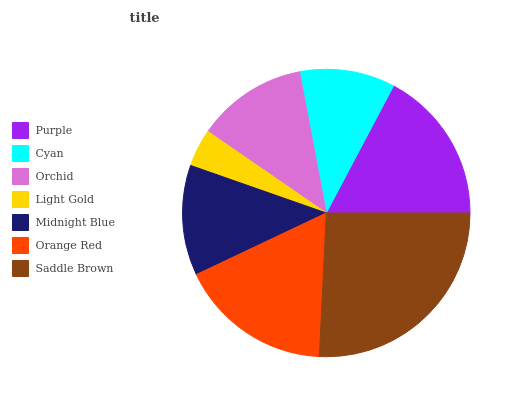Is Light Gold the minimum?
Answer yes or no. Yes. Is Saddle Brown the maximum?
Answer yes or no. Yes. Is Cyan the minimum?
Answer yes or no. No. Is Cyan the maximum?
Answer yes or no. No. Is Purple greater than Cyan?
Answer yes or no. Yes. Is Cyan less than Purple?
Answer yes or no. Yes. Is Cyan greater than Purple?
Answer yes or no. No. Is Purple less than Cyan?
Answer yes or no. No. Is Orchid the high median?
Answer yes or no. Yes. Is Orchid the low median?
Answer yes or no. Yes. Is Light Gold the high median?
Answer yes or no. No. Is Orange Red the low median?
Answer yes or no. No. 